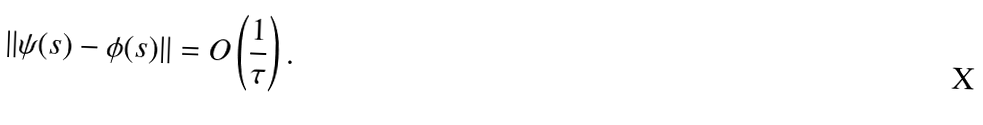Convert formula to latex. <formula><loc_0><loc_0><loc_500><loc_500>\| \psi ( s ) - \phi ( s ) \| = O \left ( \frac { 1 } { \tau } \right ) .</formula> 